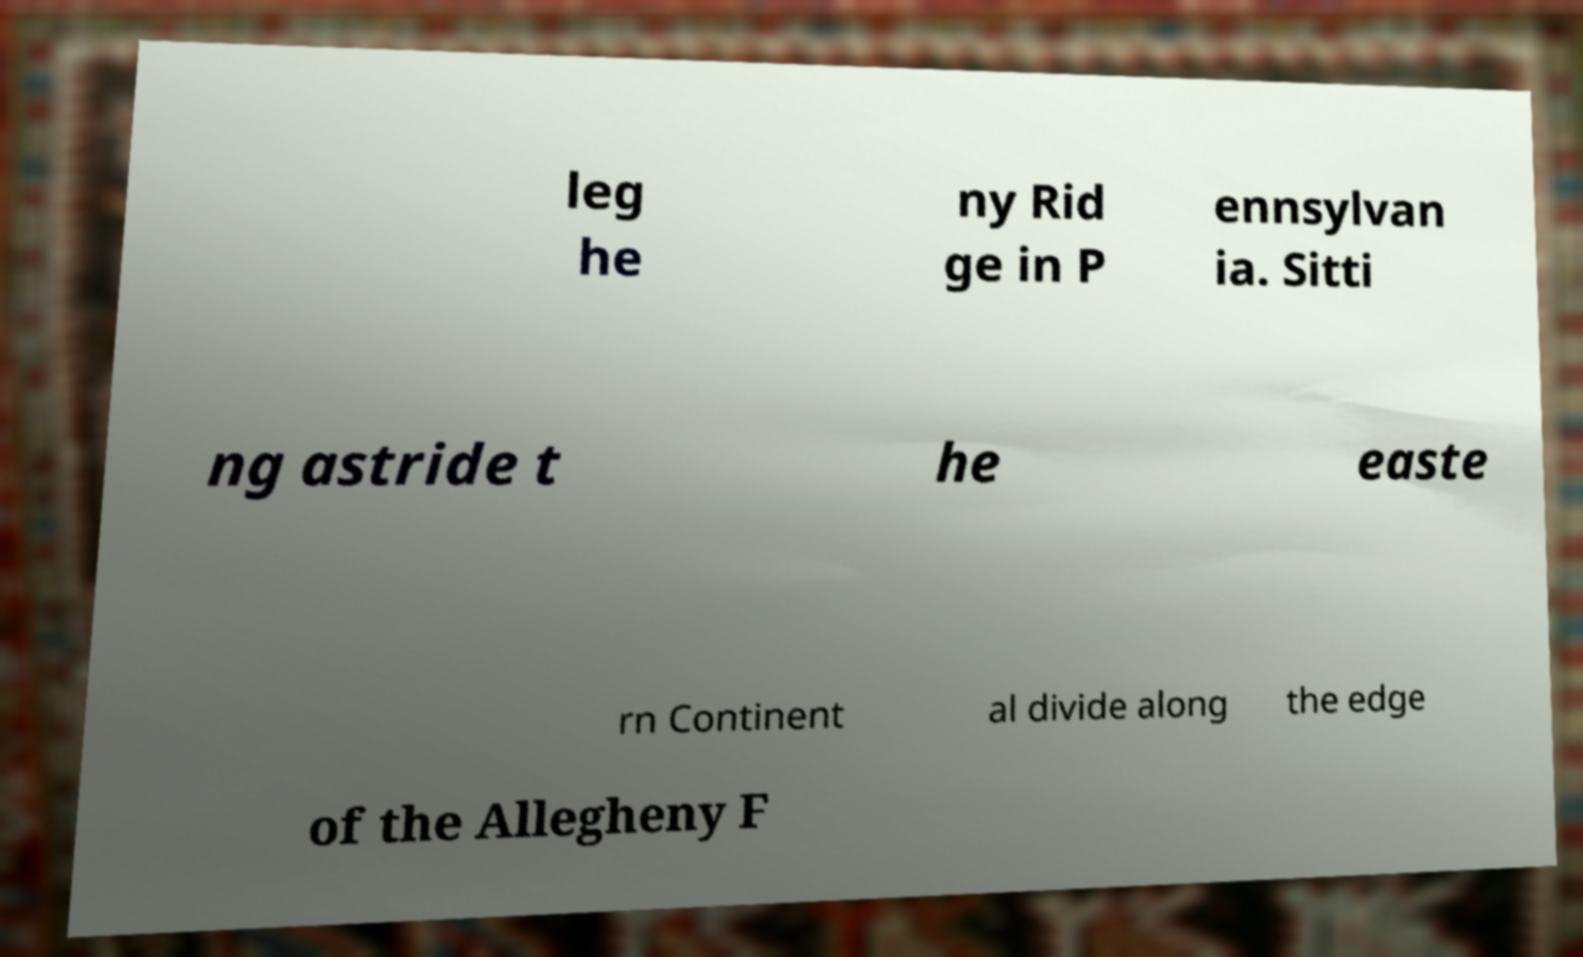Could you extract and type out the text from this image? leg he ny Rid ge in P ennsylvan ia. Sitti ng astride t he easte rn Continent al divide along the edge of the Allegheny F 